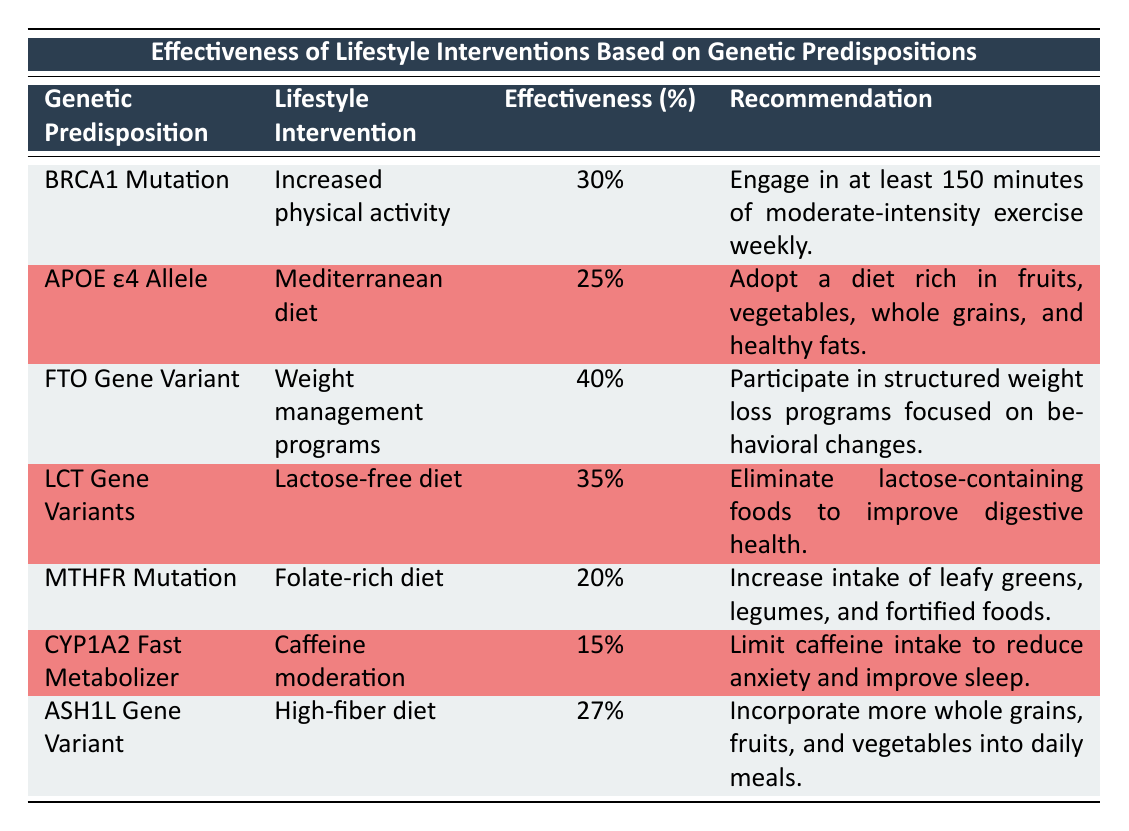What lifestyle intervention is recommended for the BRCA1 Mutation? The table shows that for the BRCA1 Mutation, the recommended lifestyle intervention is "Increased physical activity."
Answer: Increased physical activity What is the effectiveness percentage of the Mediterranean diet for individuals with the APOE ε4 Allele? According to the table, the effectiveness percentage of the Mediterranean diet for individuals with the APOE ε4 Allele is 25%.
Answer: 25% Which lifestyle intervention has the highest effectiveness percentage? By comparing the effectiveness percentages listed in the table, the Weight management programs for the FTO Gene Variant have the highest percentage at 40%.
Answer: Weight management programs Is the recommendation for caffeine moderation to reduce anxiety and improve sleep true? The table confirms that the recommendation for the lifestyle intervention of caffeine moderation for CYP1A2 Fast Metabolizer is to limit caffeine intake to reduce anxiety and improve sleep, indicating that the statement is true.
Answer: Yes What is the average effectiveness percentage of the listed lifestyle interventions? To calculate the average effectiveness, we sum the percentages: (30 + 25 + 40 + 35 + 20 + 15 + 27) = 192. There are 7 interventions, so the average is 192/7 = approximately 27.43%.
Answer: 27.43% 